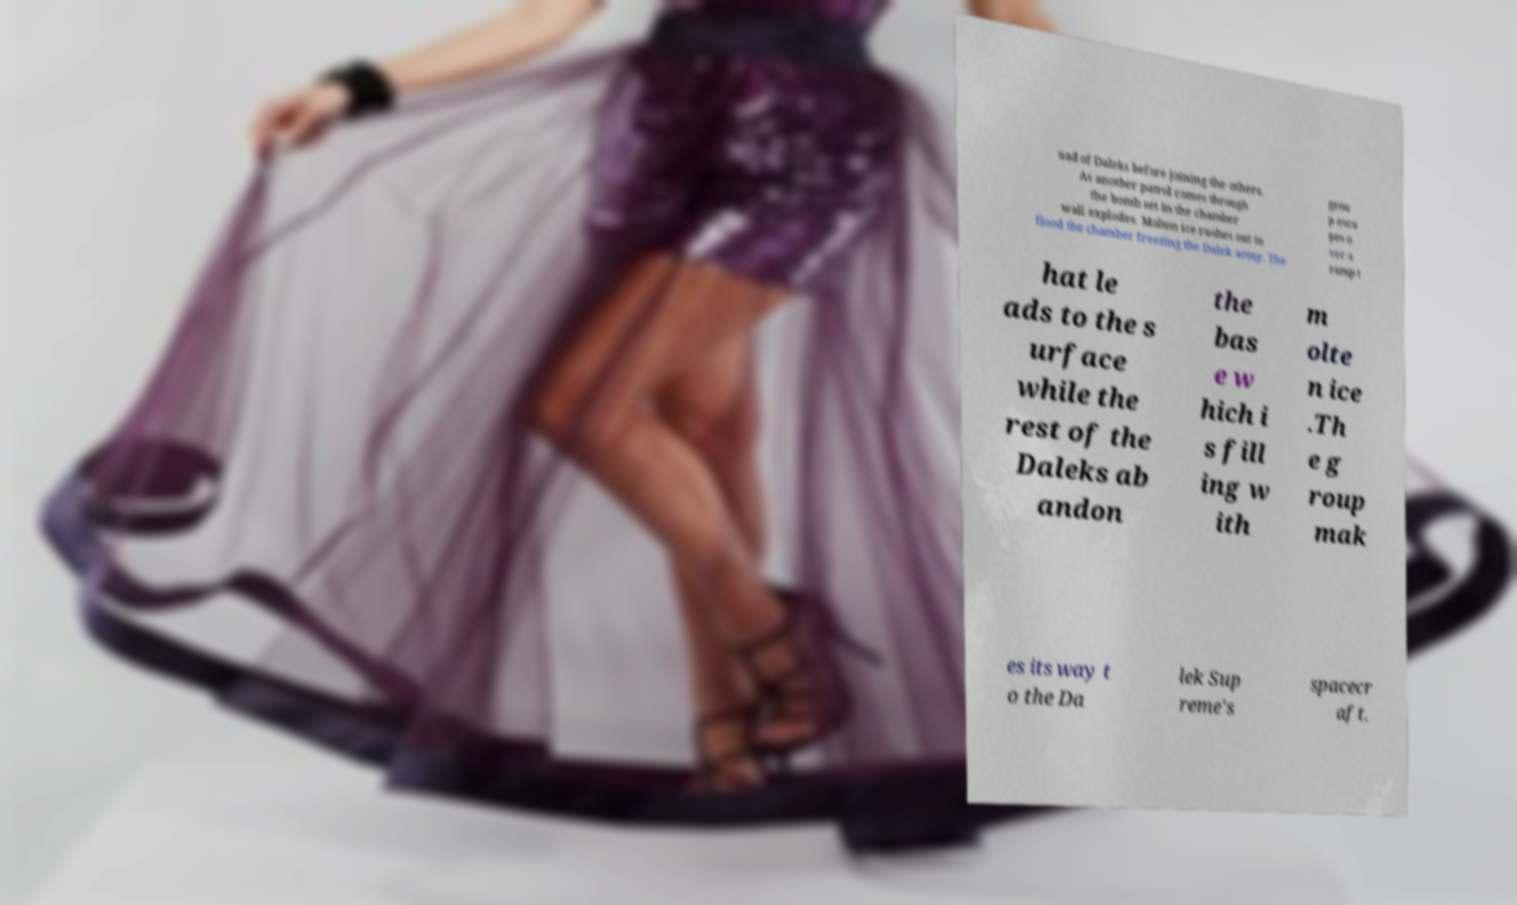I need the written content from this picture converted into text. Can you do that? uad of Daleks before joining the others. As another patrol comes through the bomb set in the chamber wall explodes. Molten ice rushes out to flood the chamber freezing the Dalek army. The grou p esca pes o ver a ramp t hat le ads to the s urface while the rest of the Daleks ab andon the bas e w hich i s fill ing w ith m olte n ice .Th e g roup mak es its way t o the Da lek Sup reme's spacecr aft. 